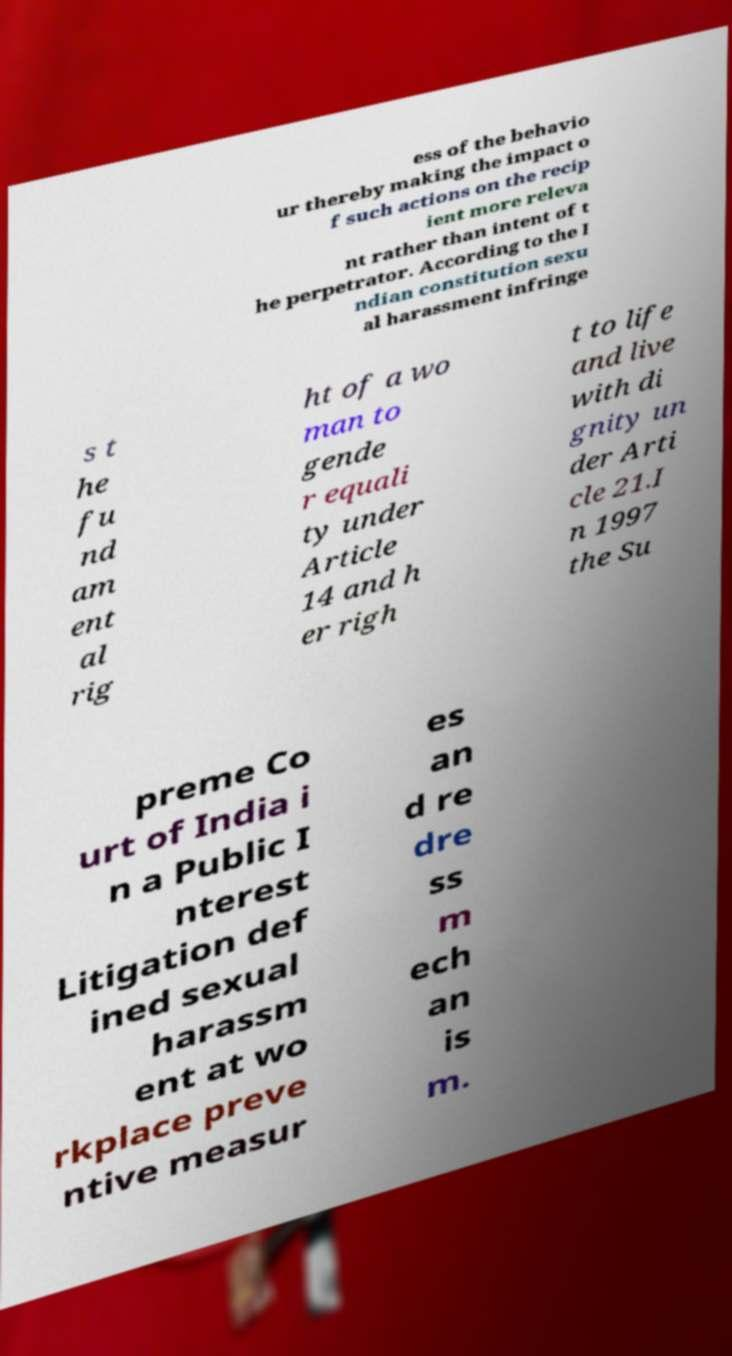There's text embedded in this image that I need extracted. Can you transcribe it verbatim? ess of the behavio ur thereby making the impact o f such actions on the recip ient more releva nt rather than intent of t he perpetrator. According to the I ndian constitution sexu al harassment infringe s t he fu nd am ent al rig ht of a wo man to gende r equali ty under Article 14 and h er righ t to life and live with di gnity un der Arti cle 21.I n 1997 the Su preme Co urt of India i n a Public I nterest Litigation def ined sexual harassm ent at wo rkplace preve ntive measur es an d re dre ss m ech an is m. 